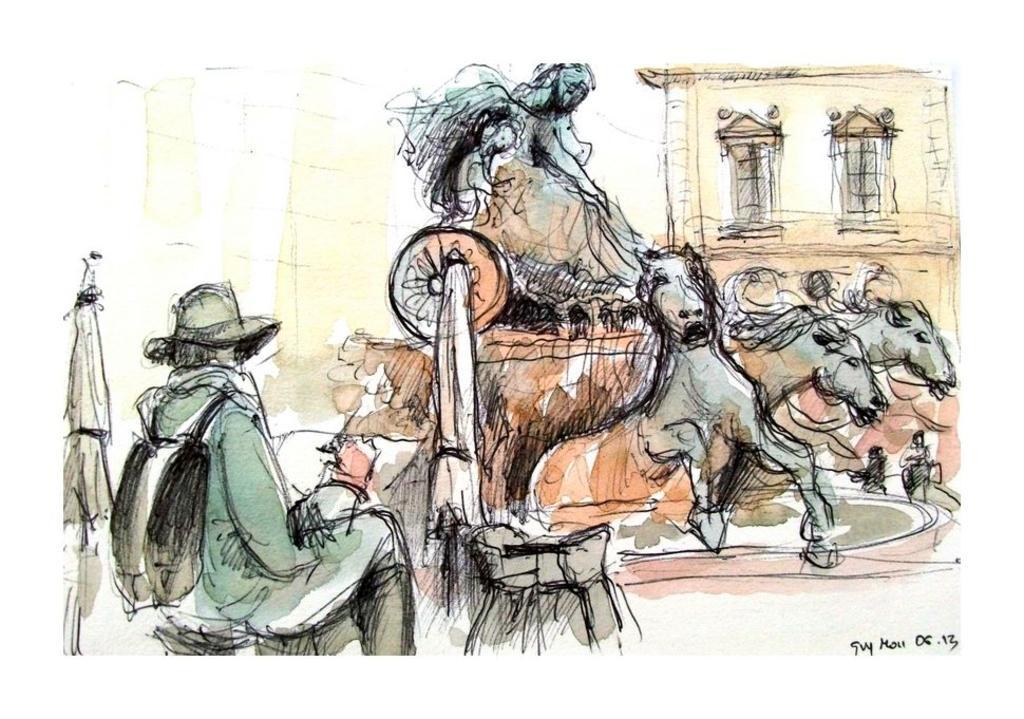Could you give a brief overview of what you see in this image? This image consists of a poster with an art on it. 